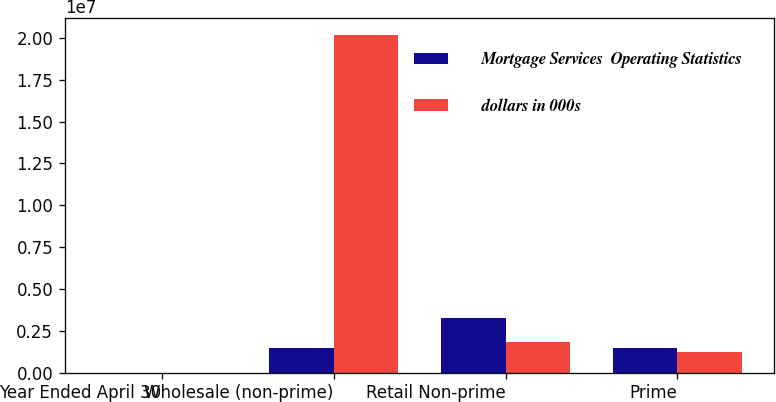Convert chart. <chart><loc_0><loc_0><loc_500><loc_500><stacked_bar_chart><ecel><fcel>Year Ended April 30<fcel>Wholesale (non-prime)<fcel>Retail Non-prime<fcel>Prime<nl><fcel>Mortgage Services  Operating Statistics<fcel>2006<fcel>1.4909e+06<fcel>3.26007e+06<fcel>1.4909e+06<nl><fcel>dollars in 000s<fcel>2004<fcel>2.0151e+07<fcel>1.84667e+06<fcel>1.25835e+06<nl></chart> 